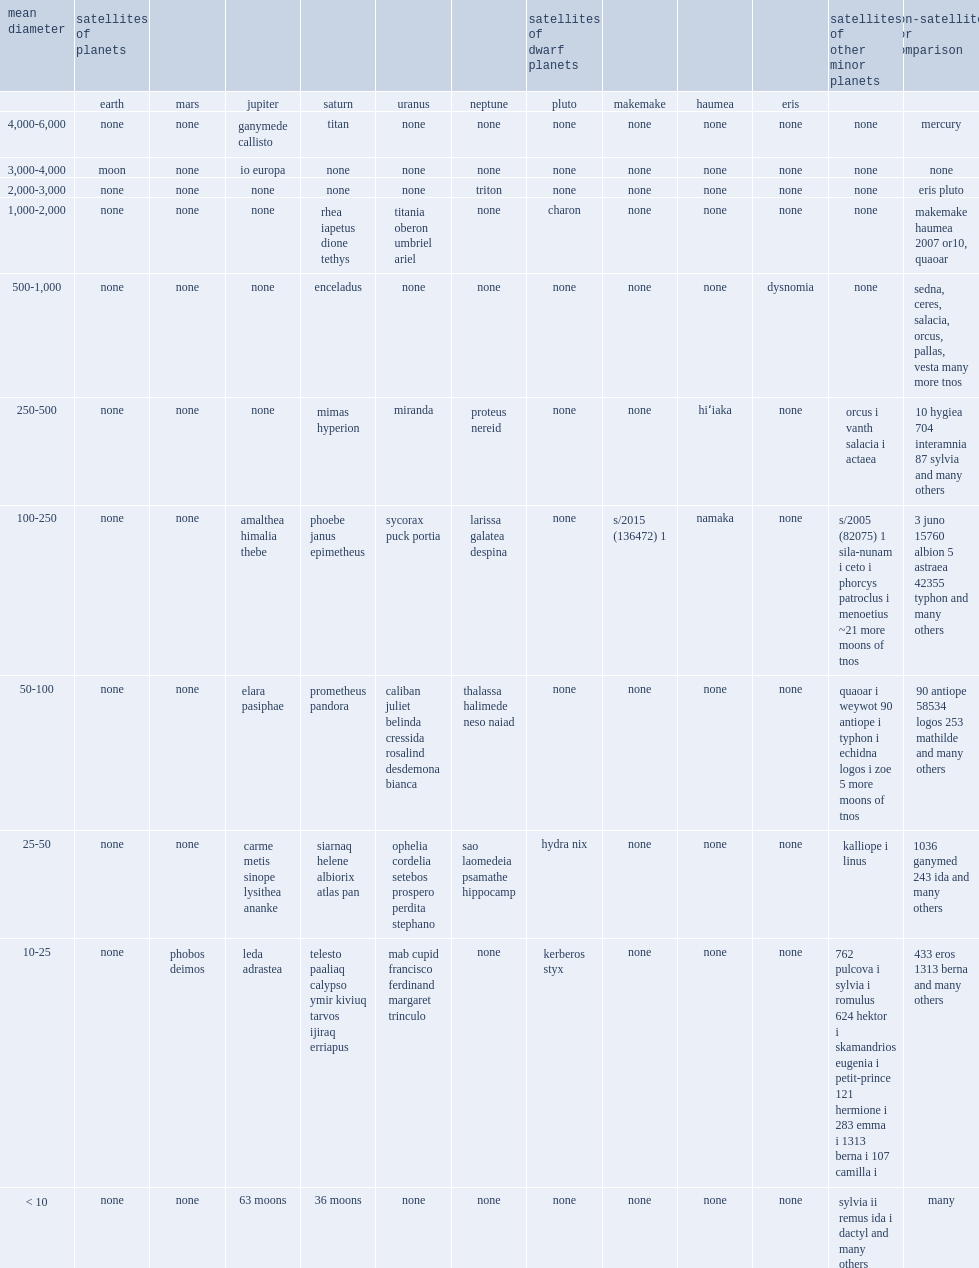What are the largest natural satellites in the solar system (those bigger than 2,500 km)? Moon ganymede callisto io europa titan. 